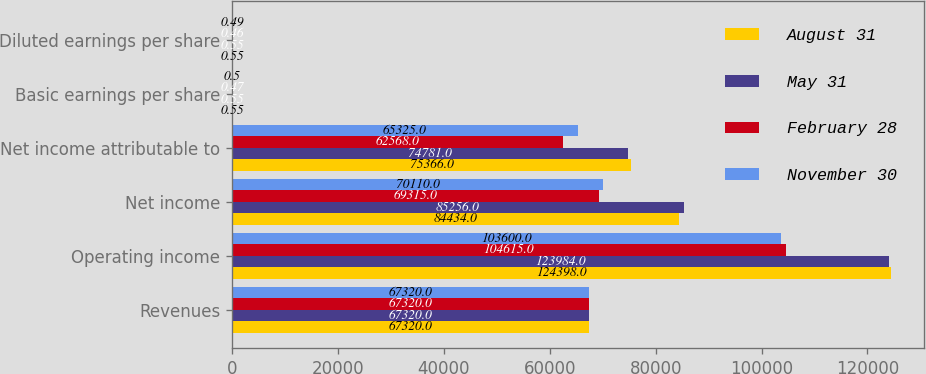Convert chart to OTSL. <chart><loc_0><loc_0><loc_500><loc_500><stacked_bar_chart><ecel><fcel>Revenues<fcel>Operating income<fcel>Net income<fcel>Net income attributable to<fcel>Basic earnings per share<fcel>Diluted earnings per share<nl><fcel>August 31<fcel>67320<fcel>124398<fcel>84434<fcel>75366<fcel>0.55<fcel>0.55<nl><fcel>May 31<fcel>67320<fcel>123984<fcel>85256<fcel>74781<fcel>0.55<fcel>0.55<nl><fcel>February 28<fcel>67320<fcel>104615<fcel>69315<fcel>62568<fcel>0.47<fcel>0.46<nl><fcel>November 30<fcel>67320<fcel>103600<fcel>70110<fcel>65325<fcel>0.5<fcel>0.49<nl></chart> 